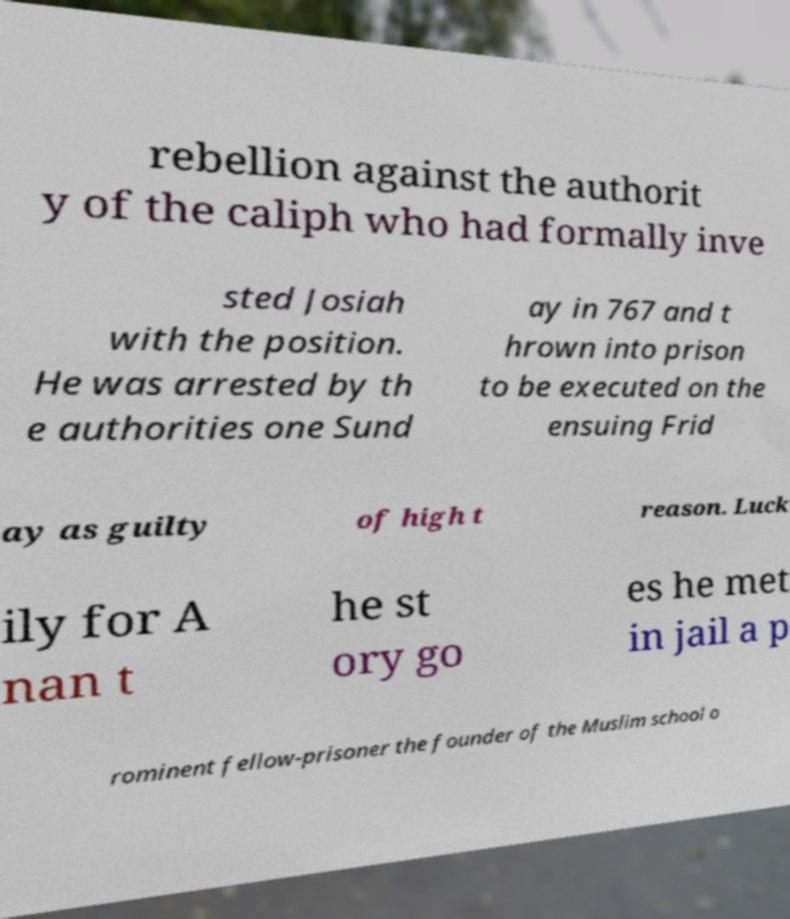Could you assist in decoding the text presented in this image and type it out clearly? rebellion against the authorit y of the caliph who had formally inve sted Josiah with the position. He was arrested by th e authorities one Sund ay in 767 and t hrown into prison to be executed on the ensuing Frid ay as guilty of high t reason. Luck ily for A nan t he st ory go es he met in jail a p rominent fellow-prisoner the founder of the Muslim school o 